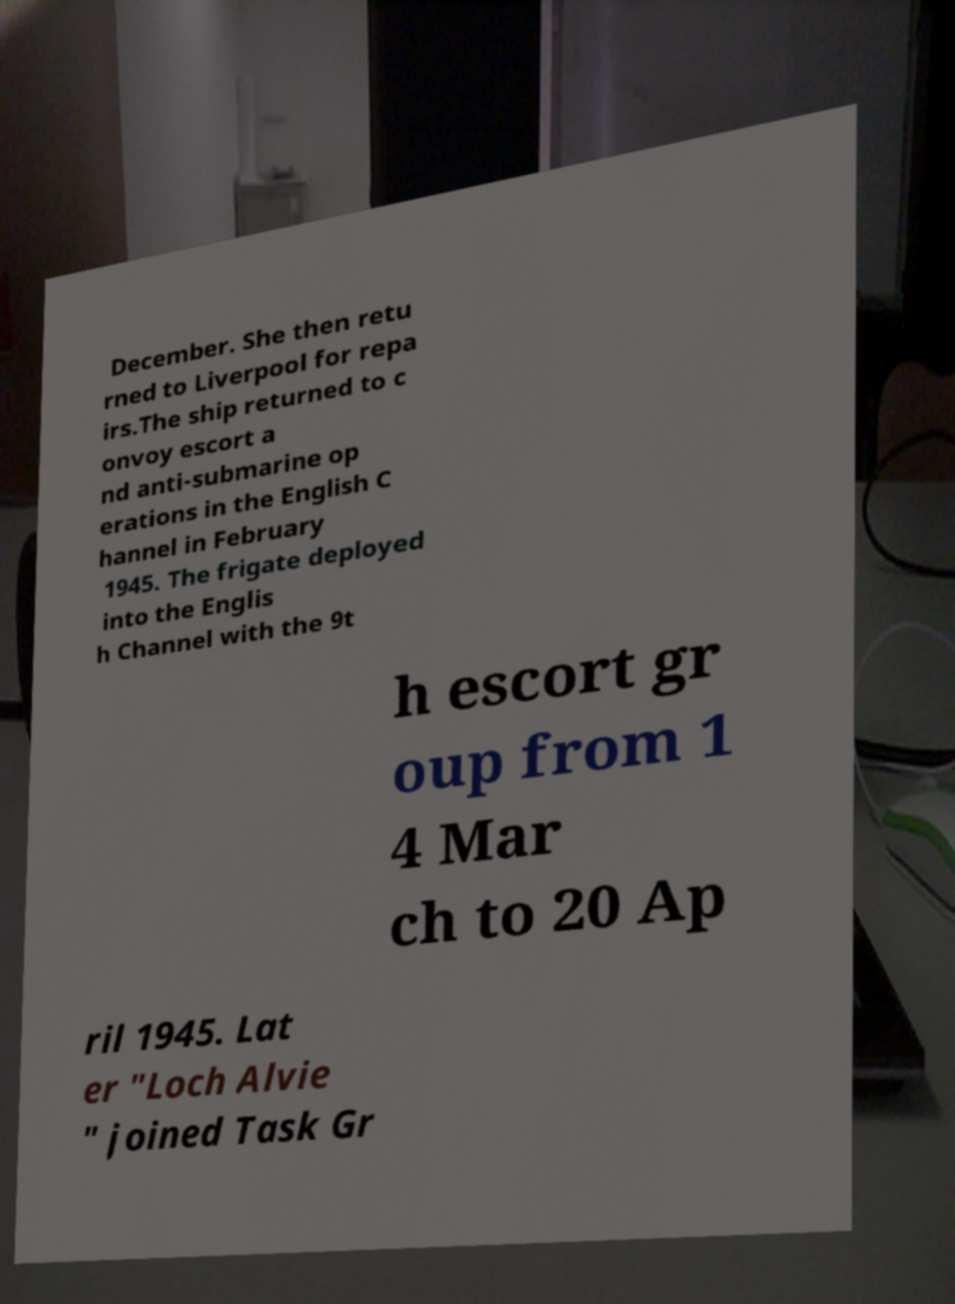Can you accurately transcribe the text from the provided image for me? December. She then retu rned to Liverpool for repa irs.The ship returned to c onvoy escort a nd anti-submarine op erations in the English C hannel in February 1945. The frigate deployed into the Englis h Channel with the 9t h escort gr oup from 1 4 Mar ch to 20 Ap ril 1945. Lat er "Loch Alvie " joined Task Gr 